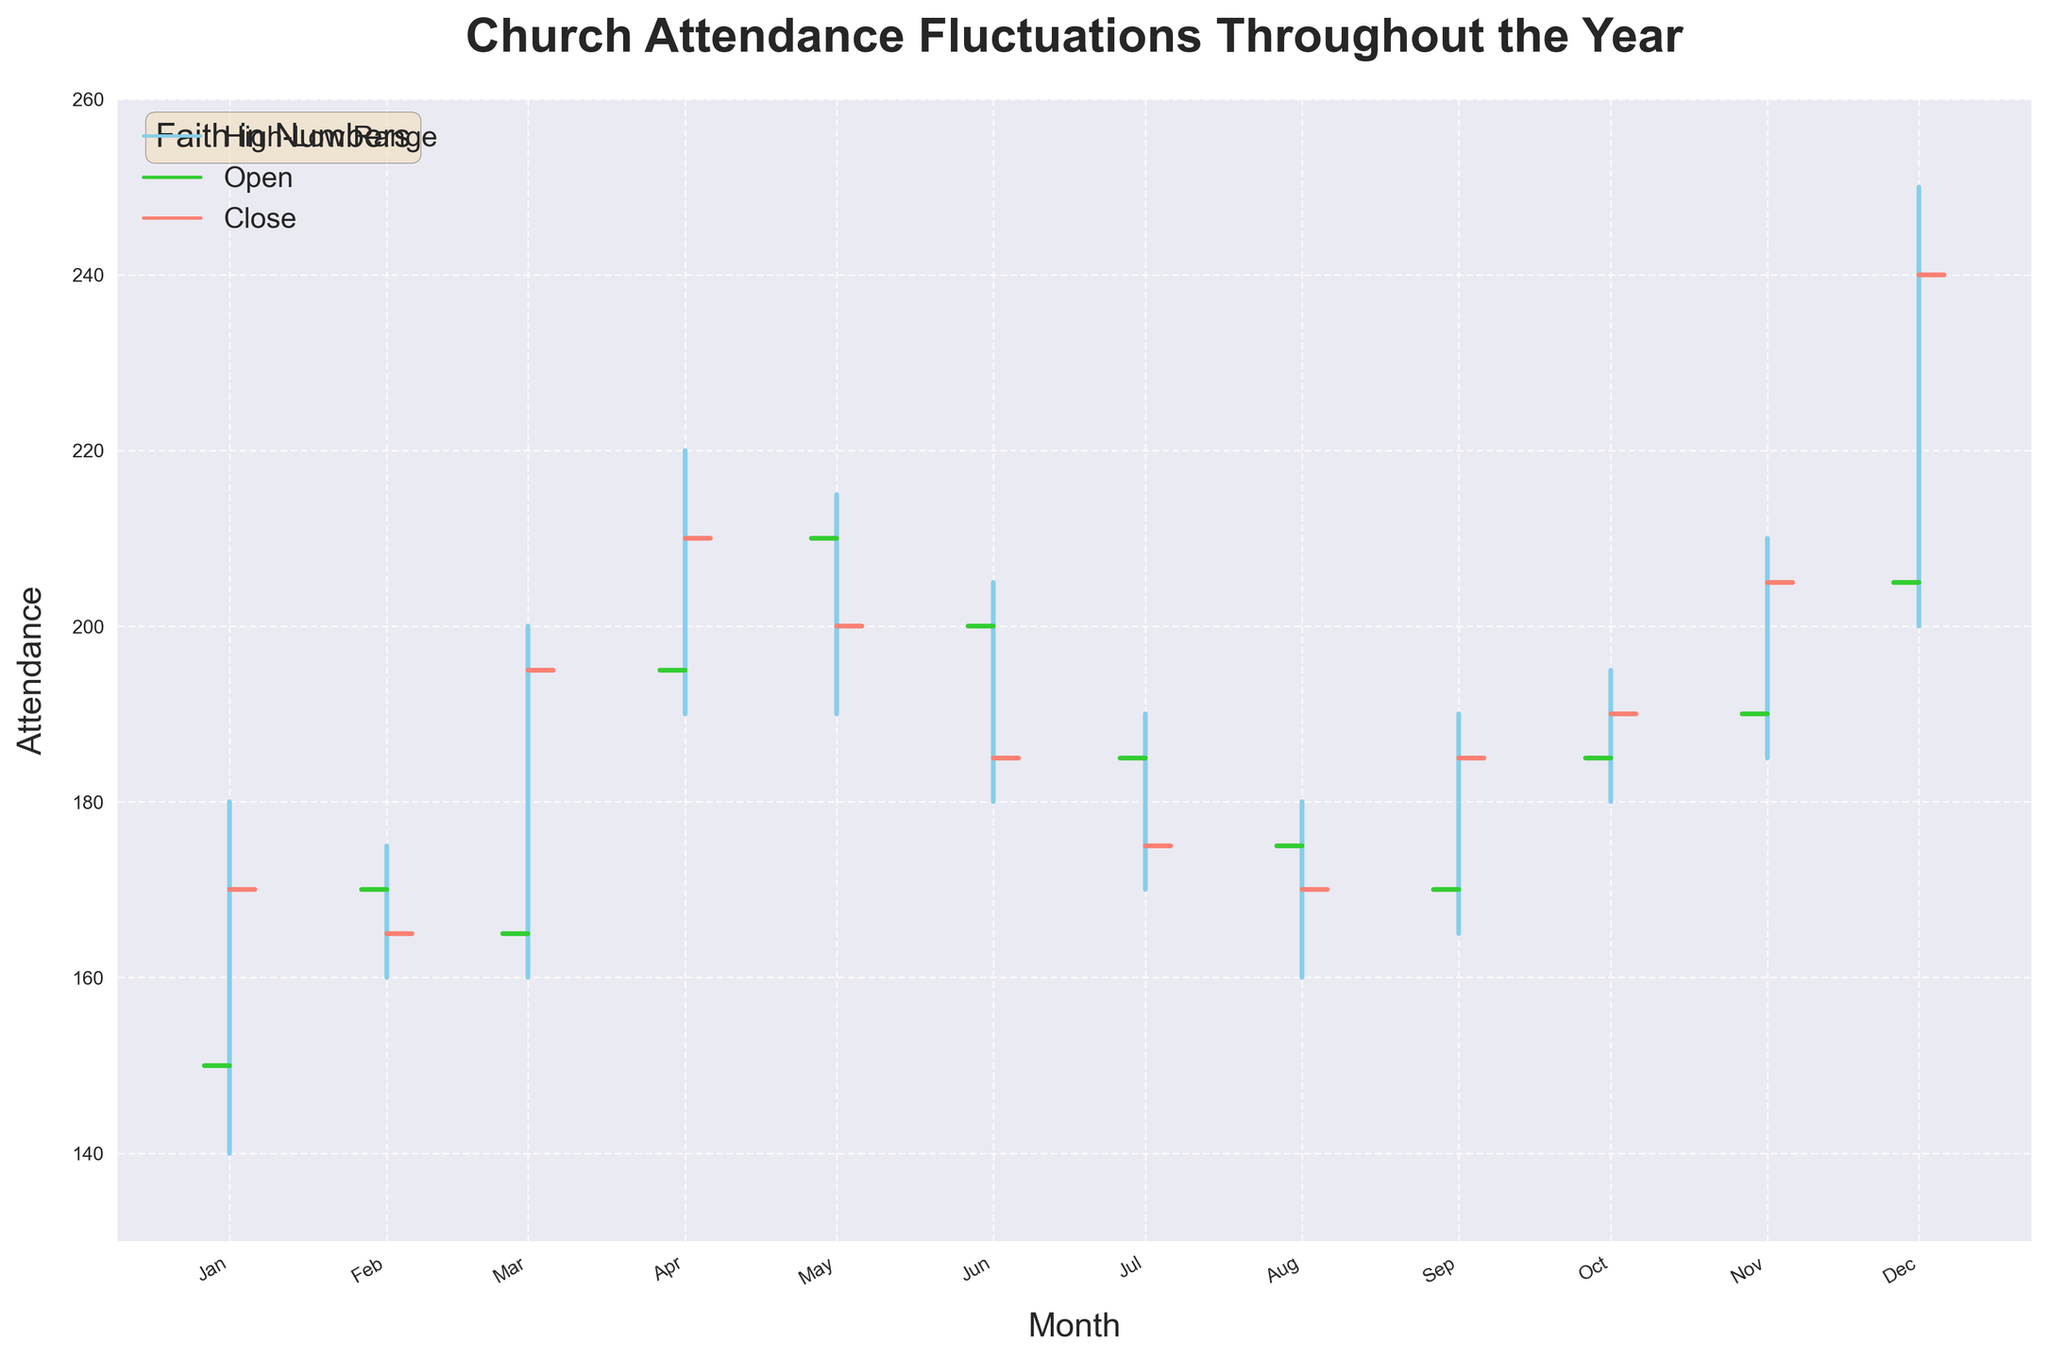what is the title of the chart? The title of the chart is indicated at the top of the figure. It reads "Church Attendance Fluctuations Throughout the Year".
Answer: Church Attendance Fluctuations Throughout the Year What does the blue vertical line represent? The blue vertical line represents the range between the highest and lowest attendance rates for each month.
Answer: High-Low Range In which month does church attendance have the highest range (difference between High and Low)? To determine the highest range, subtract the lowest value from the highest value for each month and find the largest difference. In December, the High is 250 and the Low is 200, resulting in the highest range of 50.
Answer: December What is the attendance value in January when the data was "closed"? The "Close" value for January can be found at the intersection of the short red horizontal line and the vertical line for January. The Close value is 170.
Answer: 170 Compare the Open and Close values for April. Which one is higher and by how much? The Open value for April can be seen at the start of the short green line (195), and the Close value is at the short red line (210). The Close value is higher by 210 - 195 = 15.
Answer: Close is higher by 15 How does the church attendance in the middle of the year (June) compare to the end of the year (December) in terms of Close values? The Close value for June is 185, while for December it is 240. Comparing these, the attendance in December is higher by 240 - 185 = 55.
Answer: December is higher by 55 What is the lowest attendance value in the year and in which month does it occur? The lowest attendance value can be found by looking at the lowest point of all blue vertical lines. This occurs in July where the Low is 170.
Answer: July, 170 Which month shows a decline in attendance from the Open to Close values? By examining the month-wise Open and Close values, February shows a decline from Open (170) to Close (165).
Answer: February What would the average Close attendance be for the last quarter of the year (October, November, December)? To find the average Close attendance for the last quarter, sum the Close values for October (190), November (205), and December (240) and divide by 3. (190 + 205 + 240) / 3 = 635 / 3 = 211.67
Answer: 211.67 Identify the month with the smallest High-Low attendance range and state the values. To find the smallest High-Low range, check the differences for each month. February has the smallest range, with a High of 175 and a Low of 160, resulting in a range of 15.
Answer: February, range = 15 